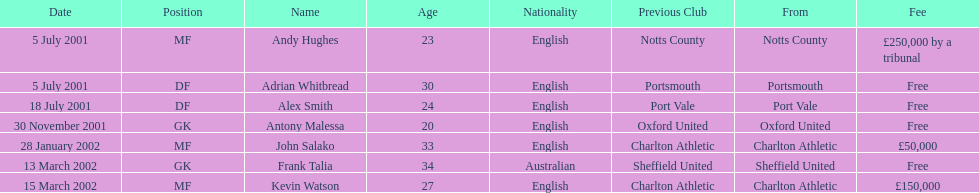I'm looking to parse the entire table for insights. Could you assist me with that? {'header': ['Date', 'Position', 'Name', 'Age', 'Nationality', 'Previous Club', 'From', 'Fee'], 'rows': [['5 July 2001', 'MF', 'Andy Hughes', '23', 'English', 'Notts County', 'Notts County', '£250,000 by a tribunal'], ['5 July 2001', 'DF', 'Adrian Whitbread', '30', 'English', 'Portsmouth', 'Portsmouth', 'Free'], ['18 July 2001', 'DF', 'Alex Smith', '24', 'English', 'Port Vale', 'Port Vale', 'Free'], ['30 November 2001', 'GK', 'Antony Malessa', '20', 'English', 'Oxford United', 'Oxford United', 'Free'], ['28 January 2002', 'MF', 'John Salako', '33', 'English', 'Charlton Athletic', 'Charlton Athletic', '£50,000'], ['13 March 2002', 'GK', 'Frank Talia', '34', 'Australian', 'Sheffield United', 'Sheffield United', 'Free'], ['15 March 2002', 'MF', 'Kevin Watson', '27', 'English', 'Charlton Athletic', 'Charlton Athletic', '£150,000']]} Are there at least 2 nationalities on the chart? Yes. 